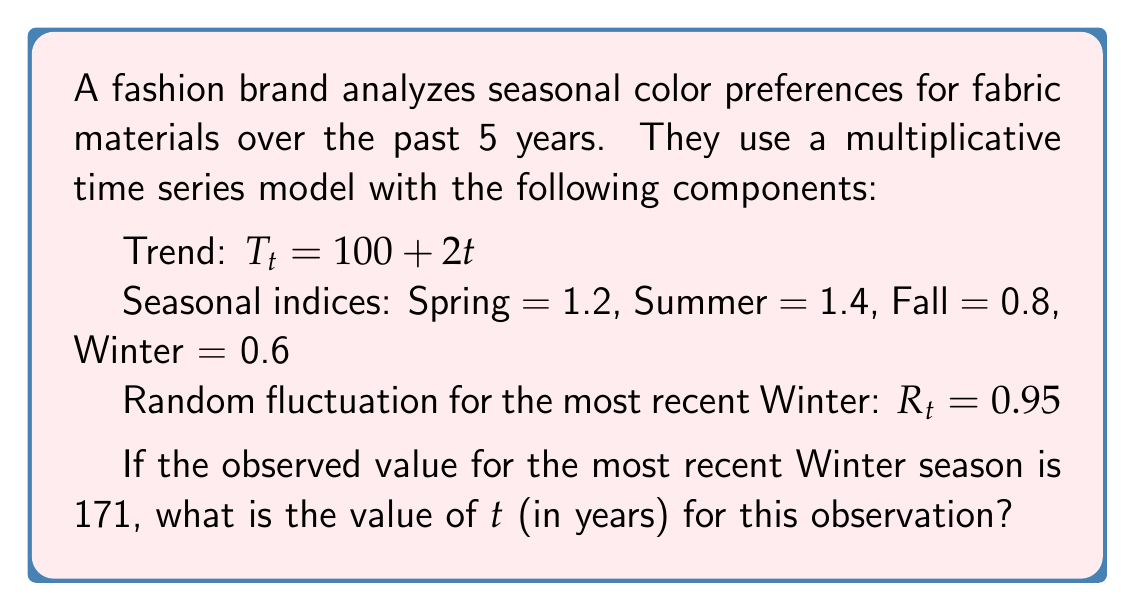Solve this math problem. To solve this problem, we'll use the multiplicative time series model:

$$Y_t = T_t \times S_t \times R_t$$

Where:
$Y_t$ is the observed value
$T_t$ is the trend component
$S_t$ is the seasonal component
$R_t$ is the random fluctuation

We're given:
$Y_t = 171$ (observed value for the most recent Winter)
$S_t = 0.6$ (Winter seasonal index)
$R_t = 0.95$ (Random fluctuation for this Winter)
$T_t = 100 + 2t$ (Trend equation)

Let's substitute these values into the multiplicative model:

$$171 = (100 + 2t) \times 0.6 \times 0.95$$

Now, let's solve for $t$:

1) First, divide both sides by $(0.6 \times 0.95)$:
   $$\frac{171}{0.6 \times 0.95} = 100 + 2t$$

2) Simplify the left side:
   $$300 = 100 + 2t$$

3) Subtract 100 from both sides:
   $$200 = 2t$$

4) Divide both sides by 2:
   $$100 = t$$

Therefore, the value of $t$ is 100, which represents 100 quarters or 25 years from the start of the time series.

Since the question asks for $t$ in years, we need to divide by 4 (as there are 4 quarters in a year):

$$t \text{ (in years)} = \frac{100}{4} = 25$$
Answer: $t = 25$ years 